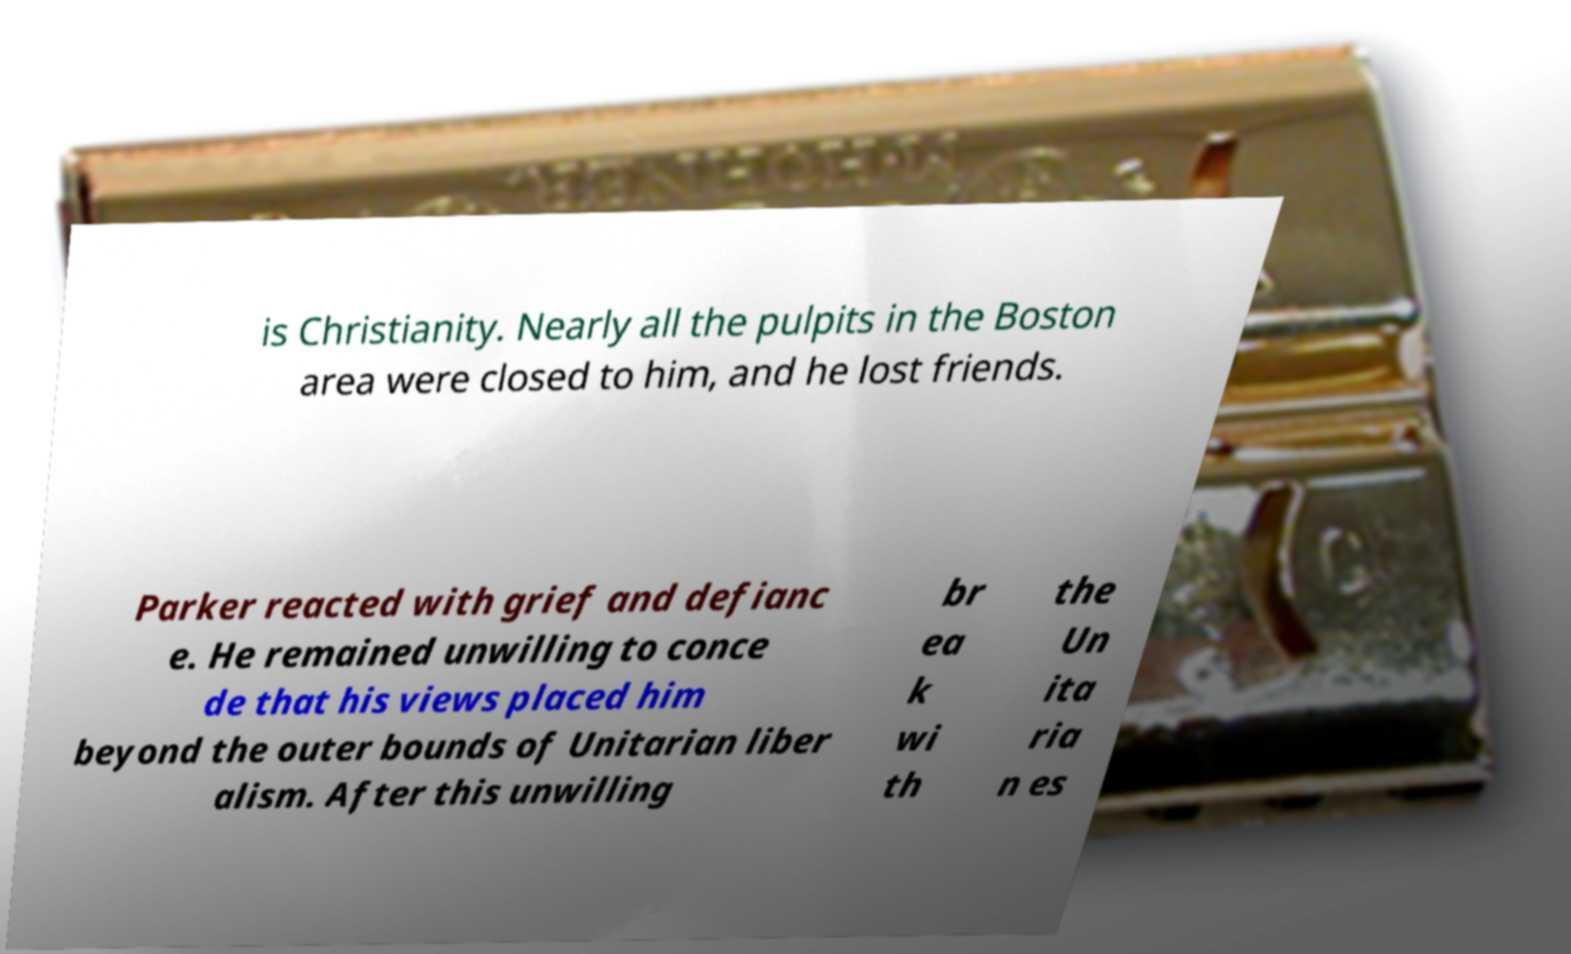Can you read and provide the text displayed in the image?This photo seems to have some interesting text. Can you extract and type it out for me? is Christianity. Nearly all the pulpits in the Boston area were closed to him, and he lost friends. Parker reacted with grief and defianc e. He remained unwilling to conce de that his views placed him beyond the outer bounds of Unitarian liber alism. After this unwilling br ea k wi th the Un ita ria n es 